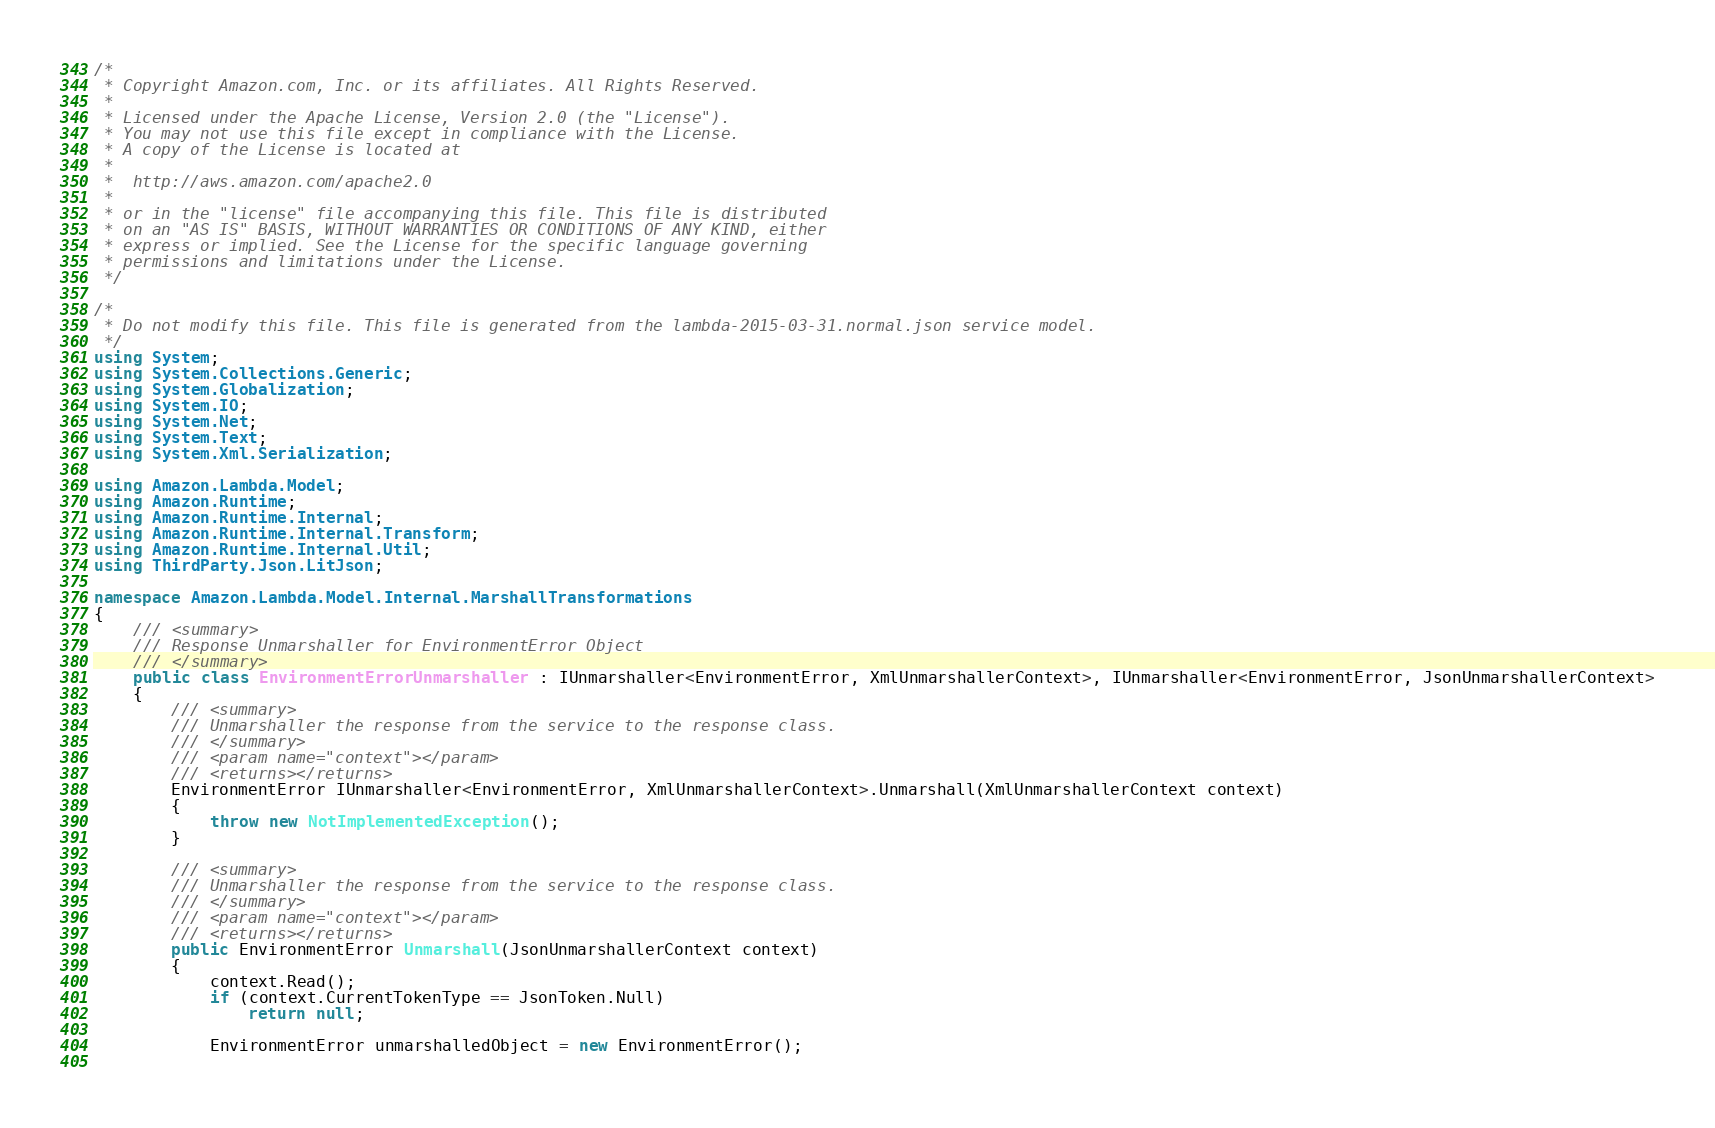Convert code to text. <code><loc_0><loc_0><loc_500><loc_500><_C#_>/*
 * Copyright Amazon.com, Inc. or its affiliates. All Rights Reserved.
 * 
 * Licensed under the Apache License, Version 2.0 (the "License").
 * You may not use this file except in compliance with the License.
 * A copy of the License is located at
 * 
 *  http://aws.amazon.com/apache2.0
 * 
 * or in the "license" file accompanying this file. This file is distributed
 * on an "AS IS" BASIS, WITHOUT WARRANTIES OR CONDITIONS OF ANY KIND, either
 * express or implied. See the License for the specific language governing
 * permissions and limitations under the License.
 */

/*
 * Do not modify this file. This file is generated from the lambda-2015-03-31.normal.json service model.
 */
using System;
using System.Collections.Generic;
using System.Globalization;
using System.IO;
using System.Net;
using System.Text;
using System.Xml.Serialization;

using Amazon.Lambda.Model;
using Amazon.Runtime;
using Amazon.Runtime.Internal;
using Amazon.Runtime.Internal.Transform;
using Amazon.Runtime.Internal.Util;
using ThirdParty.Json.LitJson;

namespace Amazon.Lambda.Model.Internal.MarshallTransformations
{
    /// <summary>
    /// Response Unmarshaller for EnvironmentError Object
    /// </summary>  
    public class EnvironmentErrorUnmarshaller : IUnmarshaller<EnvironmentError, XmlUnmarshallerContext>, IUnmarshaller<EnvironmentError, JsonUnmarshallerContext>
    {
        /// <summary>
        /// Unmarshaller the response from the service to the response class.
        /// </summary>  
        /// <param name="context"></param>
        /// <returns></returns>
        EnvironmentError IUnmarshaller<EnvironmentError, XmlUnmarshallerContext>.Unmarshall(XmlUnmarshallerContext context)
        {
            throw new NotImplementedException();
        }

        /// <summary>
        /// Unmarshaller the response from the service to the response class.
        /// </summary>  
        /// <param name="context"></param>
        /// <returns></returns>
        public EnvironmentError Unmarshall(JsonUnmarshallerContext context)
        {
            context.Read();
            if (context.CurrentTokenType == JsonToken.Null) 
                return null;

            EnvironmentError unmarshalledObject = new EnvironmentError();
        </code> 